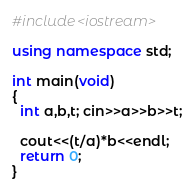<code> <loc_0><loc_0><loc_500><loc_500><_C++_>#include<iostream>

using namespace std;

int main(void)
{
  int a,b,t; cin>>a>>b>>t;
  
  cout<<(t/a)*b<<endl;
  return 0;
}</code> 